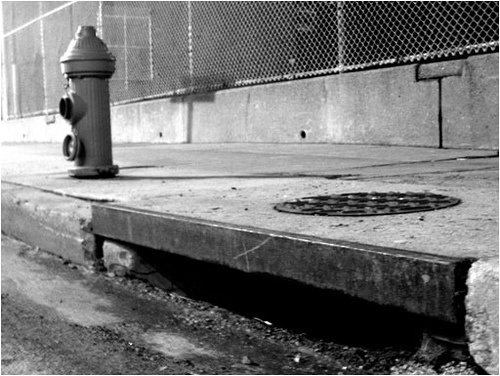Describe the objects in this image and their specific colors. I can see a fire hydrant in white, gray, black, lightgray, and darkgray tones in this image. 